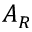<formula> <loc_0><loc_0><loc_500><loc_500>A _ { R }</formula> 